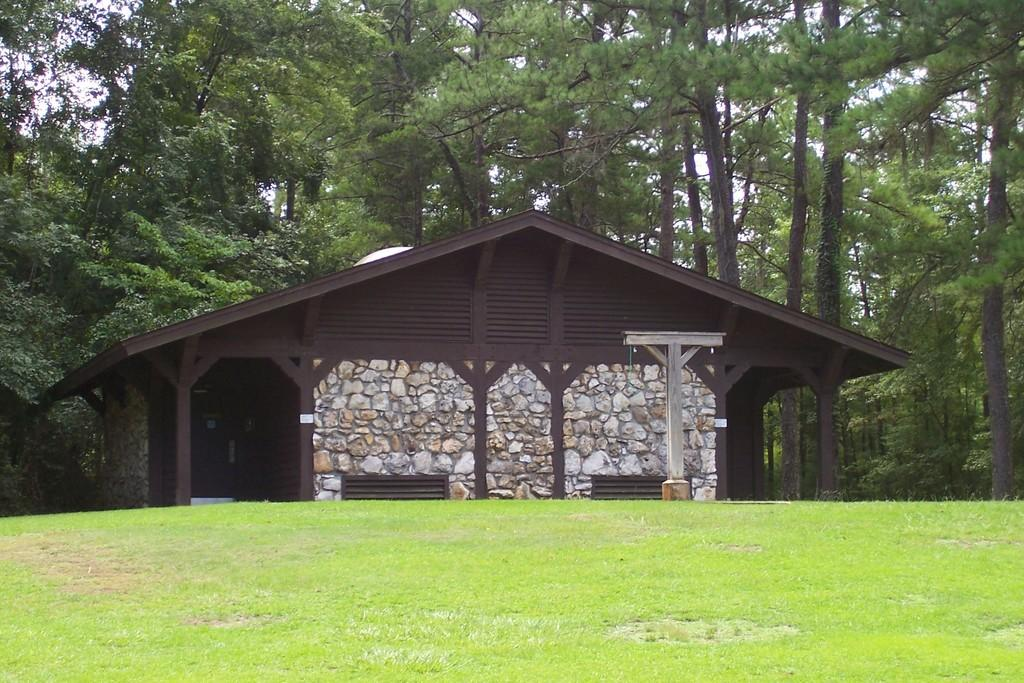What type of vegetation is present in the image? There is grass in the image. What color is the house in the image? The house in the image is brown-colored. What can be seen in the background of the image? There are trees in the background of the image. Are there any pigs participating in the event depicted in the image? There is no event or pigs present in the image; it features grass, a brown-colored house, and trees in the background. What type of apparatus is being used by the person in the image? There is no person or apparatus present in the image. 